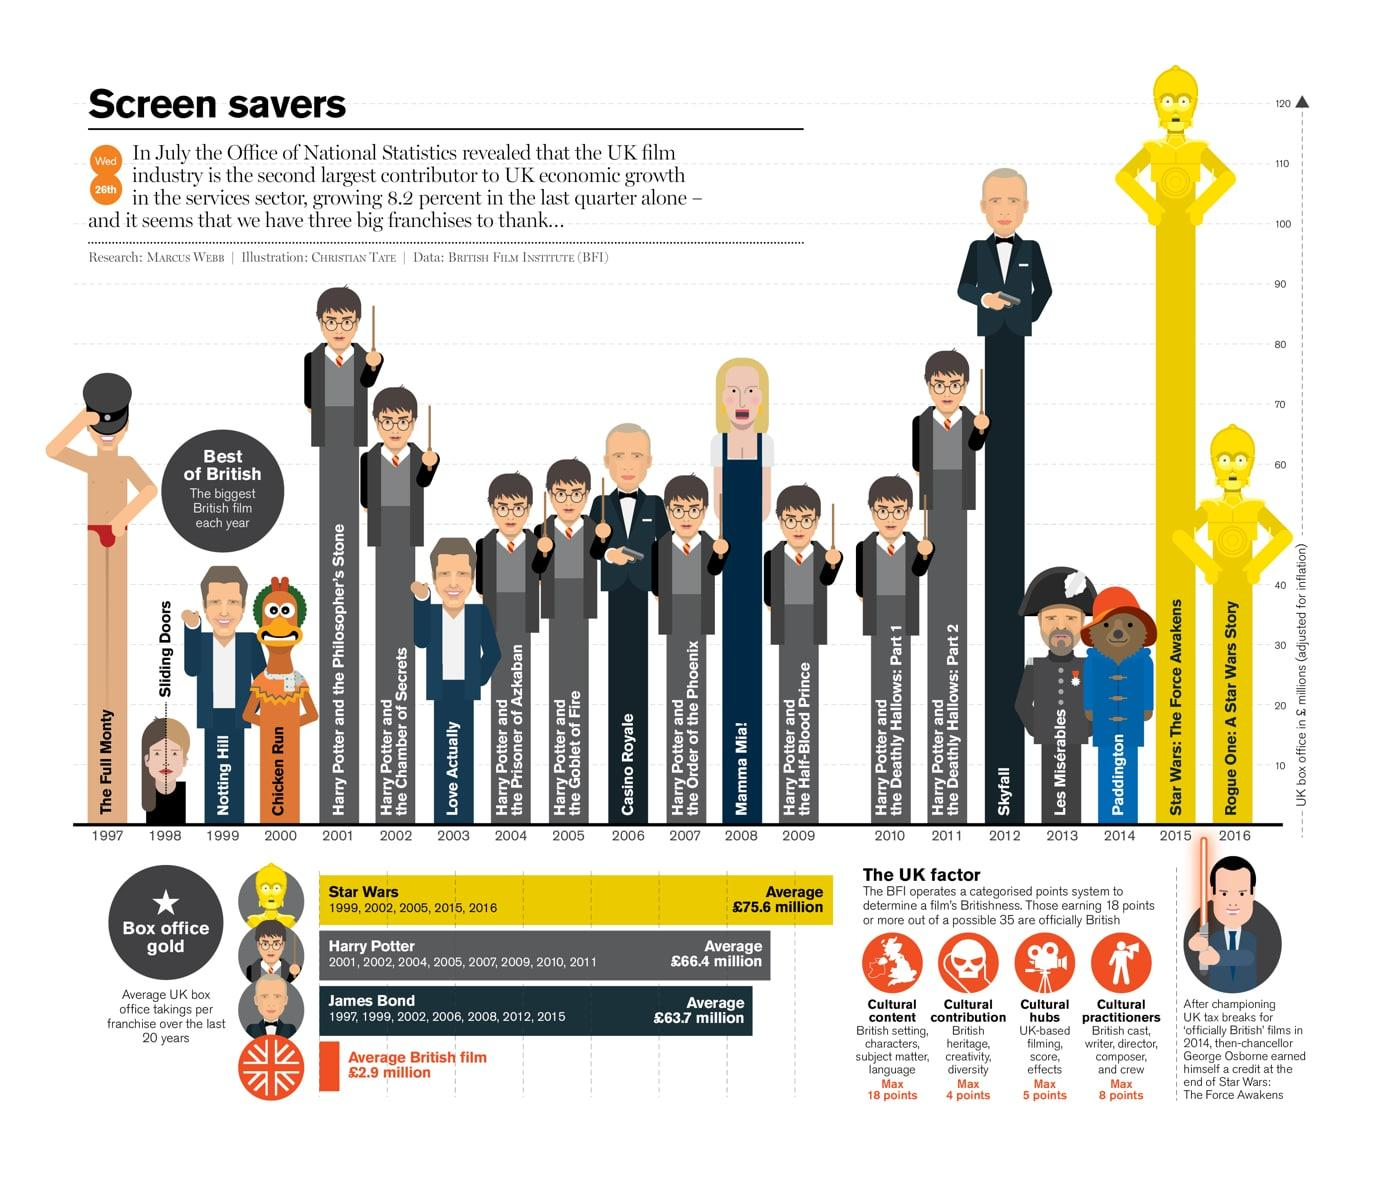List a handful of essential elements in this visual. The average revenue generated by British films is approximately £2.9 million. Star Wars: The Force Awakens, a movie that surpassed 120 million pounds at the UK box office, is a record-breaking film that continues to captivate audiences around the world. The average revenue generated by the James Bond series at the UK box office is estimated to be approximately £63.7 million. The last installment of the Harry Potter film series was released in 2011. The Harry Potter series has generated an average revenue of approximately £66.4 million at the UK box office. 